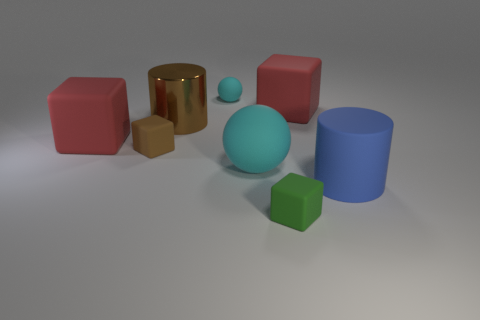Can you tell me which object seems the closest and which seems the farthest in the image? The closest object appears to be the small green cube on the right, positioned in the foreground. In contrast, the cyan matte sphere towards the back center of the image seems to be the farthest from the viewer's perspective. 